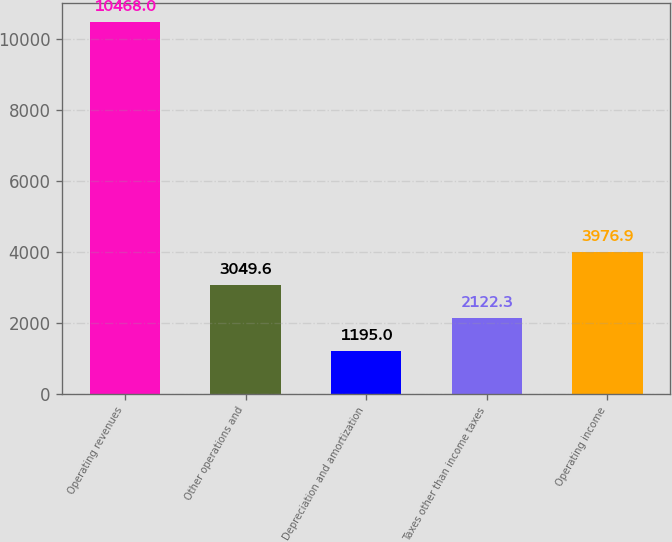Convert chart to OTSL. <chart><loc_0><loc_0><loc_500><loc_500><bar_chart><fcel>Operating revenues<fcel>Other operations and<fcel>Depreciation and amortization<fcel>Taxes other than income taxes<fcel>Operating income<nl><fcel>10468<fcel>3049.6<fcel>1195<fcel>2122.3<fcel>3976.9<nl></chart> 